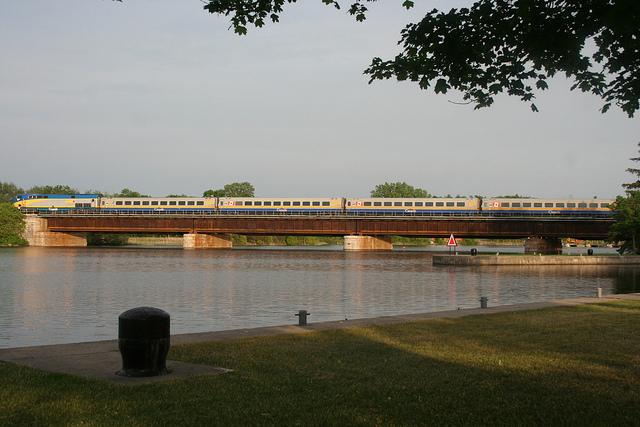How many cars does the train have?
Keep it brief. 4. What color is the fire hydrant?
Short answer required. Red. How many pillars support the bridge?
Answer briefly. 4. Which direction is the train traveling?
Keep it brief. Left. Does this scene have a skyline?
Be succinct. No. What is holding up the bridge?
Quick response, please. Pillars. What color is the object at the end of the concrete pier?
Write a very short answer. Red. Is there snow?
Answer briefly. No. 